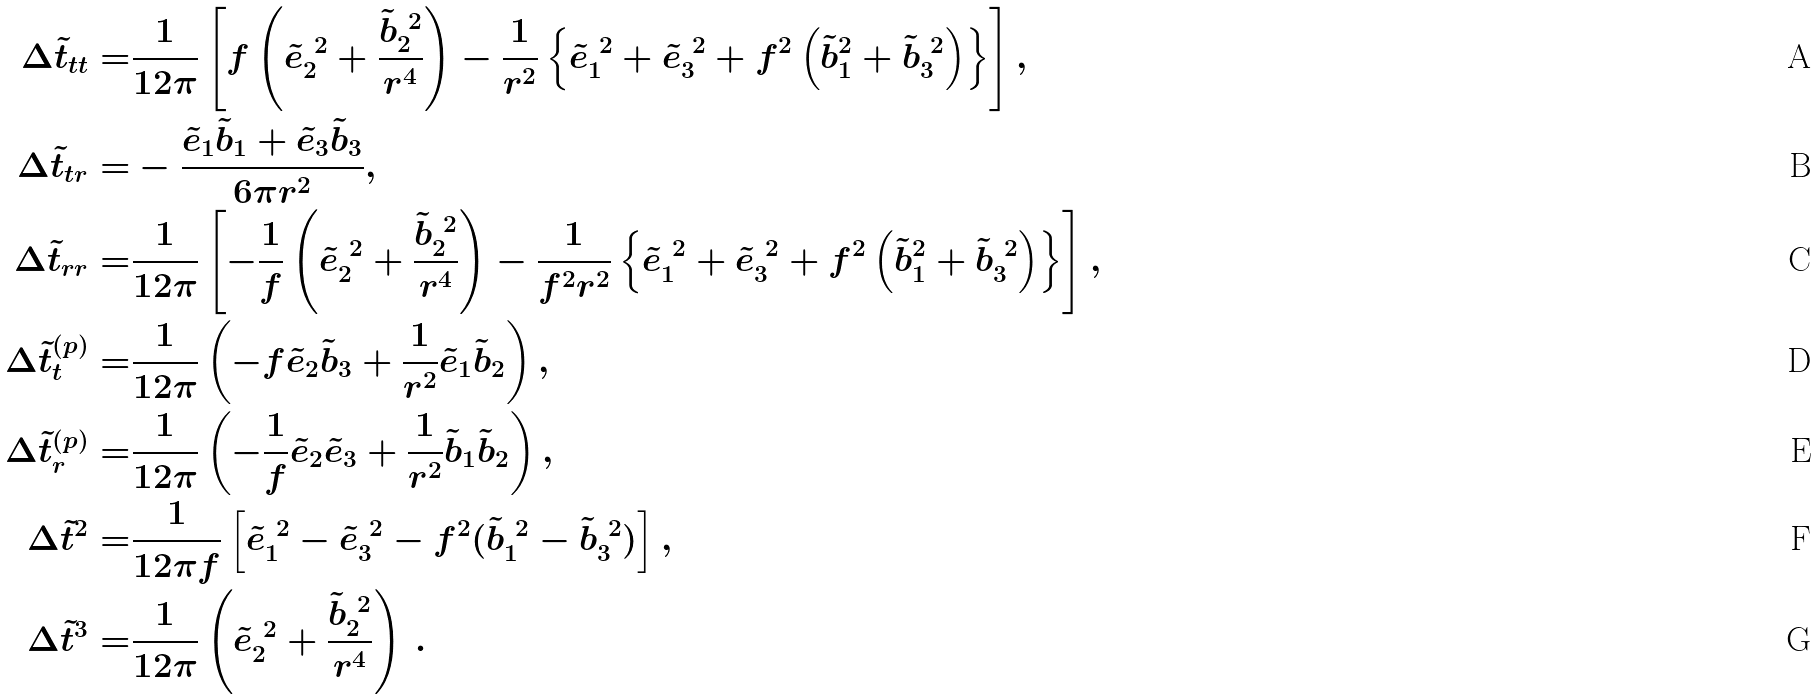Convert formula to latex. <formula><loc_0><loc_0><loc_500><loc_500>\Delta \tilde { t } _ { t t } = & \frac { 1 } { 1 2 \pi } \left [ f \left ( \tilde { e } _ { 2 } ^ { \ 2 } + \frac { \tilde { b } _ { 2 } ^ { \ 2 } } { r ^ { 4 } } \right ) - \frac { 1 } { r ^ { 2 } } \left \{ \tilde { e } _ { 1 } ^ { \ 2 } + \tilde { e } _ { 3 } ^ { \ 2 } + f ^ { 2 } \left ( \tilde { b } _ { 1 } ^ { 2 } + \tilde { b } _ { 3 } ^ { \ 2 } \right ) \right \} \right ] , \\ \Delta \tilde { t } _ { t r } = & - \frac { \tilde { e } _ { 1 } \tilde { b } _ { 1 } + \tilde { e } _ { 3 } \tilde { b } _ { 3 } } { 6 \pi r ^ { 2 } } , \\ \Delta \tilde { t } _ { r r } = & \frac { 1 } { 1 2 \pi } \left [ - \frac { 1 } { f } \left ( \tilde { e } _ { 2 } ^ { \ 2 } + \frac { \tilde { b } _ { 2 } ^ { \ 2 } } { r ^ { 4 } } \right ) - \frac { 1 } { f ^ { 2 } r ^ { 2 } } \left \{ \tilde { e } _ { 1 } ^ { \ 2 } + \tilde { e } _ { 3 } ^ { \ 2 } + f ^ { 2 } \left ( \tilde { b } _ { 1 } ^ { 2 } + \tilde { b } _ { 3 } ^ { \ 2 } \right ) \right \} \right ] , \\ \Delta \tilde { t } _ { t } ^ { ( p ) } = & \frac { 1 } { 1 2 \pi } \left ( - f \tilde { e } _ { 2 } \tilde { b } _ { 3 } + \frac { 1 } { r ^ { 2 } } \tilde { e } _ { 1 } \tilde { b } _ { 2 } \right ) , \\ \Delta \tilde { t } _ { r } ^ { ( p ) } = & \frac { 1 } { 1 2 \pi } \left ( - \frac { 1 } { f } \tilde { e } _ { 2 } \tilde { e } _ { 3 } + \frac { 1 } { r ^ { 2 } } \tilde { b } _ { 1 } \tilde { b } _ { 2 } \right ) , \\ \Delta \tilde { t } ^ { 2 } = & \frac { 1 } { 1 2 \pi f } \left [ \tilde { e } _ { 1 } ^ { \ 2 } - \tilde { e } _ { 3 } ^ { \ 2 } - f ^ { 2 } ( \tilde { b } _ { 1 } ^ { \ 2 } - \tilde { b } _ { 3 } ^ { \ 2 } ) \right ] , \\ \Delta \tilde { t } ^ { 3 } = & \frac { 1 } { 1 2 \pi } \left ( \tilde { e } _ { 2 } ^ { \ 2 } + \frac { \tilde { b } _ { 2 } ^ { \ 2 } } { r ^ { 4 } } \right ) \, .</formula> 